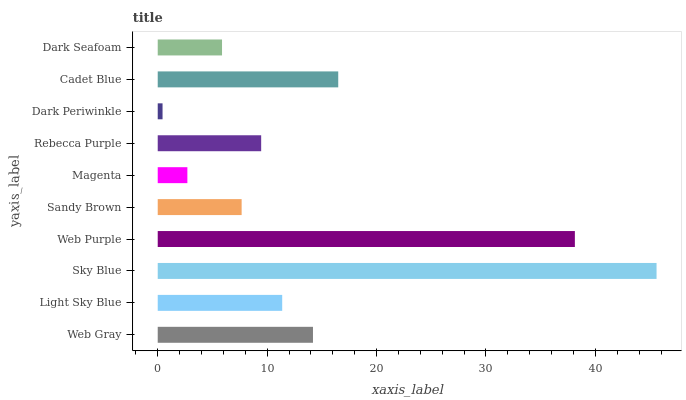Is Dark Periwinkle the minimum?
Answer yes or no. Yes. Is Sky Blue the maximum?
Answer yes or no. Yes. Is Light Sky Blue the minimum?
Answer yes or no. No. Is Light Sky Blue the maximum?
Answer yes or no. No. Is Web Gray greater than Light Sky Blue?
Answer yes or no. Yes. Is Light Sky Blue less than Web Gray?
Answer yes or no. Yes. Is Light Sky Blue greater than Web Gray?
Answer yes or no. No. Is Web Gray less than Light Sky Blue?
Answer yes or no. No. Is Light Sky Blue the high median?
Answer yes or no. Yes. Is Rebecca Purple the low median?
Answer yes or no. Yes. Is Cadet Blue the high median?
Answer yes or no. No. Is Dark Periwinkle the low median?
Answer yes or no. No. 